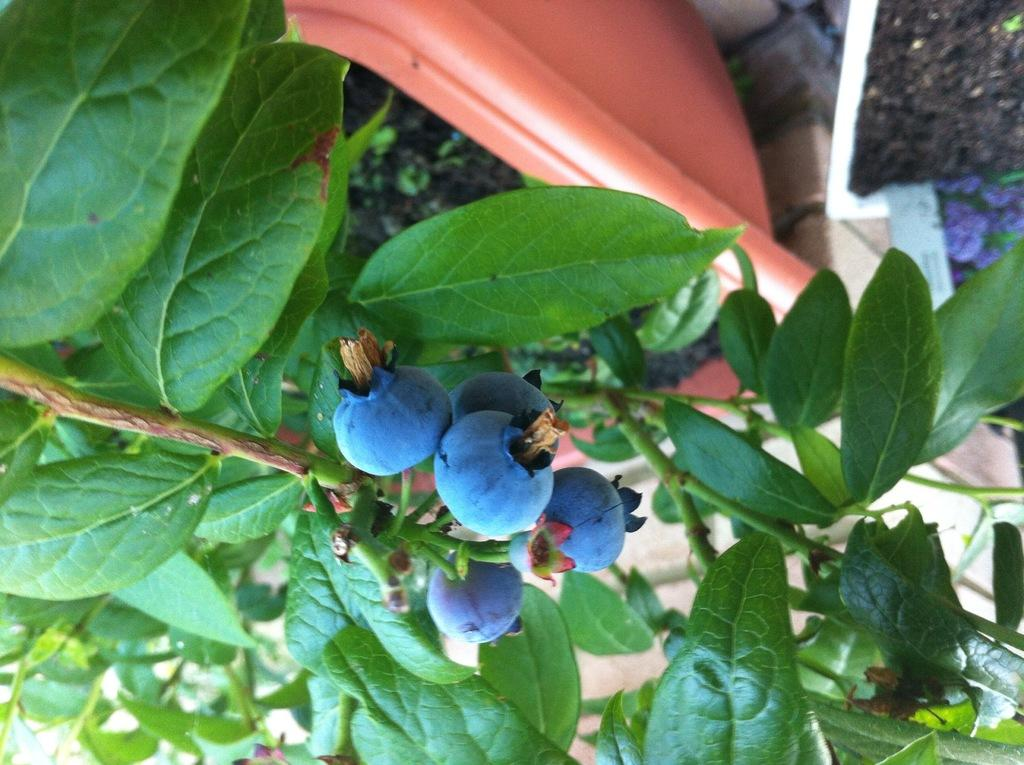What type of fruit can be seen on the plants in the image? There are blueberries on plants in the image. What can be found in the pots in the image? There are pots with soil in the image. Can you see the father holding a goldfish in the image? There is no father or goldfish present in the image; it features blueberries on plants and pots with soil. 